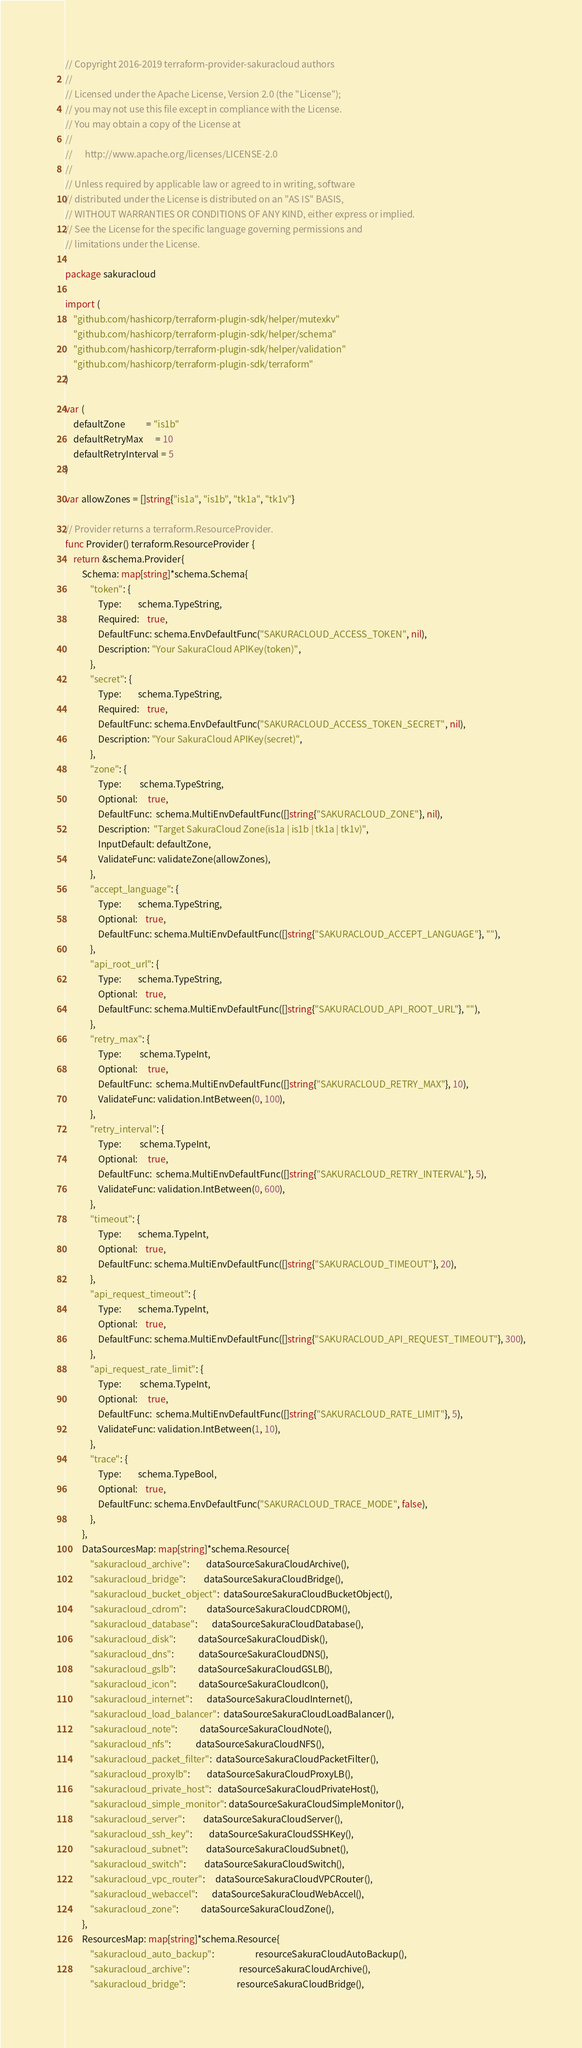<code> <loc_0><loc_0><loc_500><loc_500><_Go_>// Copyright 2016-2019 terraform-provider-sakuracloud authors
//
// Licensed under the Apache License, Version 2.0 (the "License");
// you may not use this file except in compliance with the License.
// You may obtain a copy of the License at
//
//      http://www.apache.org/licenses/LICENSE-2.0
//
// Unless required by applicable law or agreed to in writing, software
// distributed under the License is distributed on an "AS IS" BASIS,
// WITHOUT WARRANTIES OR CONDITIONS OF ANY KIND, either express or implied.
// See the License for the specific language governing permissions and
// limitations under the License.

package sakuracloud

import (
	"github.com/hashicorp/terraform-plugin-sdk/helper/mutexkv"
	"github.com/hashicorp/terraform-plugin-sdk/helper/schema"
	"github.com/hashicorp/terraform-plugin-sdk/helper/validation"
	"github.com/hashicorp/terraform-plugin-sdk/terraform"
)

var (
	defaultZone          = "is1b"
	defaultRetryMax      = 10
	defaultRetryInterval = 5
)

var allowZones = []string{"is1a", "is1b", "tk1a", "tk1v"}

// Provider returns a terraform.ResourceProvider.
func Provider() terraform.ResourceProvider {
	return &schema.Provider{
		Schema: map[string]*schema.Schema{
			"token": {
				Type:        schema.TypeString,
				Required:    true,
				DefaultFunc: schema.EnvDefaultFunc("SAKURACLOUD_ACCESS_TOKEN", nil),
				Description: "Your SakuraCloud APIKey(token)",
			},
			"secret": {
				Type:        schema.TypeString,
				Required:    true,
				DefaultFunc: schema.EnvDefaultFunc("SAKURACLOUD_ACCESS_TOKEN_SECRET", nil),
				Description: "Your SakuraCloud APIKey(secret)",
			},
			"zone": {
				Type:         schema.TypeString,
				Optional:     true,
				DefaultFunc:  schema.MultiEnvDefaultFunc([]string{"SAKURACLOUD_ZONE"}, nil),
				Description:  "Target SakuraCloud Zone(is1a | is1b | tk1a | tk1v)",
				InputDefault: defaultZone,
				ValidateFunc: validateZone(allowZones),
			},
			"accept_language": {
				Type:        schema.TypeString,
				Optional:    true,
				DefaultFunc: schema.MultiEnvDefaultFunc([]string{"SAKURACLOUD_ACCEPT_LANGUAGE"}, ""),
			},
			"api_root_url": {
				Type:        schema.TypeString,
				Optional:    true,
				DefaultFunc: schema.MultiEnvDefaultFunc([]string{"SAKURACLOUD_API_ROOT_URL"}, ""),
			},
			"retry_max": {
				Type:         schema.TypeInt,
				Optional:     true,
				DefaultFunc:  schema.MultiEnvDefaultFunc([]string{"SAKURACLOUD_RETRY_MAX"}, 10),
				ValidateFunc: validation.IntBetween(0, 100),
			},
			"retry_interval": {
				Type:         schema.TypeInt,
				Optional:     true,
				DefaultFunc:  schema.MultiEnvDefaultFunc([]string{"SAKURACLOUD_RETRY_INTERVAL"}, 5),
				ValidateFunc: validation.IntBetween(0, 600),
			},
			"timeout": {
				Type:        schema.TypeInt,
				Optional:    true,
				DefaultFunc: schema.MultiEnvDefaultFunc([]string{"SAKURACLOUD_TIMEOUT"}, 20),
			},
			"api_request_timeout": {
				Type:        schema.TypeInt,
				Optional:    true,
				DefaultFunc: schema.MultiEnvDefaultFunc([]string{"SAKURACLOUD_API_REQUEST_TIMEOUT"}, 300),
			},
			"api_request_rate_limit": {
				Type:         schema.TypeInt,
				Optional:     true,
				DefaultFunc:  schema.MultiEnvDefaultFunc([]string{"SAKURACLOUD_RATE_LIMIT"}, 5),
				ValidateFunc: validation.IntBetween(1, 10),
			},
			"trace": {
				Type:        schema.TypeBool,
				Optional:    true,
				DefaultFunc: schema.EnvDefaultFunc("SAKURACLOUD_TRACE_MODE", false),
			},
		},
		DataSourcesMap: map[string]*schema.Resource{
			"sakuracloud_archive":        dataSourceSakuraCloudArchive(),
			"sakuracloud_bridge":         dataSourceSakuraCloudBridge(),
			"sakuracloud_bucket_object":  dataSourceSakuraCloudBucketObject(),
			"sakuracloud_cdrom":          dataSourceSakuraCloudCDROM(),
			"sakuracloud_database":       dataSourceSakuraCloudDatabase(),
			"sakuracloud_disk":           dataSourceSakuraCloudDisk(),
			"sakuracloud_dns":            dataSourceSakuraCloudDNS(),
			"sakuracloud_gslb":           dataSourceSakuraCloudGSLB(),
			"sakuracloud_icon":           dataSourceSakuraCloudIcon(),
			"sakuracloud_internet":       dataSourceSakuraCloudInternet(),
			"sakuracloud_load_balancer":  dataSourceSakuraCloudLoadBalancer(),
			"sakuracloud_note":           dataSourceSakuraCloudNote(),
			"sakuracloud_nfs":            dataSourceSakuraCloudNFS(),
			"sakuracloud_packet_filter":  dataSourceSakuraCloudPacketFilter(),
			"sakuracloud_proxylb":        dataSourceSakuraCloudProxyLB(),
			"sakuracloud_private_host":   dataSourceSakuraCloudPrivateHost(),
			"sakuracloud_simple_monitor": dataSourceSakuraCloudSimpleMonitor(),
			"sakuracloud_server":         dataSourceSakuraCloudServer(),
			"sakuracloud_ssh_key":        dataSourceSakuraCloudSSHKey(),
			"sakuracloud_subnet":         dataSourceSakuraCloudSubnet(),
			"sakuracloud_switch":         dataSourceSakuraCloudSwitch(),
			"sakuracloud_vpc_router":     dataSourceSakuraCloudVPCRouter(),
			"sakuracloud_webaccel":       dataSourceSakuraCloudWebAccel(),
			"sakuracloud_zone":           dataSourceSakuraCloudZone(),
		},
		ResourcesMap: map[string]*schema.Resource{
			"sakuracloud_auto_backup":                    resourceSakuraCloudAutoBackup(),
			"sakuracloud_archive":                        resourceSakuraCloudArchive(),
			"sakuracloud_bridge":                         resourceSakuraCloudBridge(),</code> 